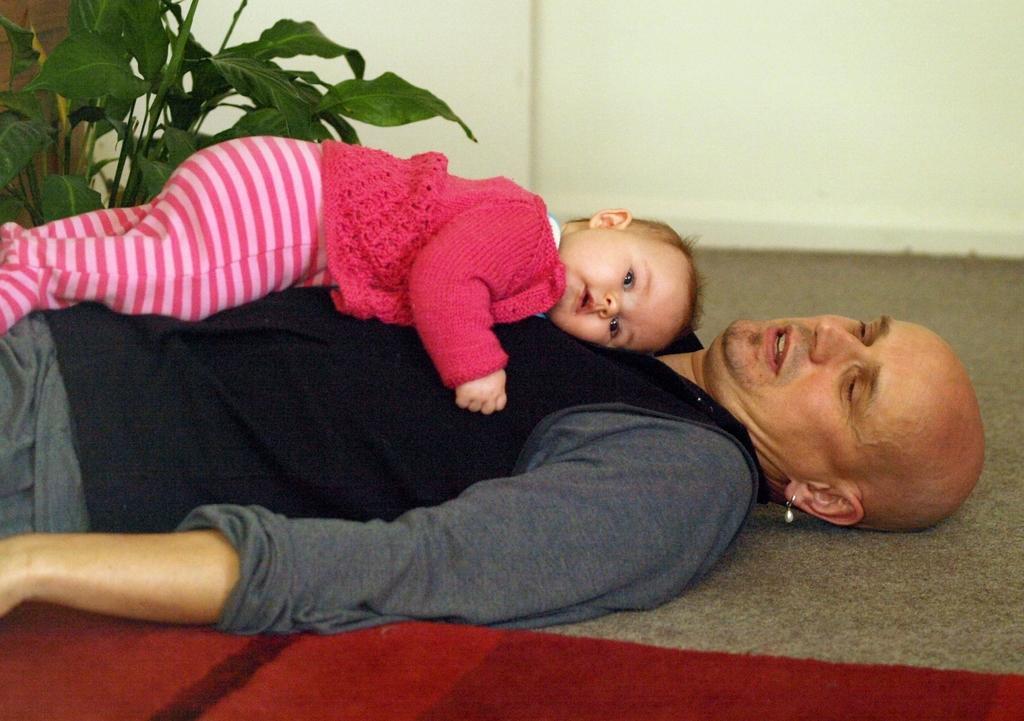Please provide a concise description of this image. In this picture we can see a man with a baby on him, carpet on the floor, plant and in the background we can see the wall. 